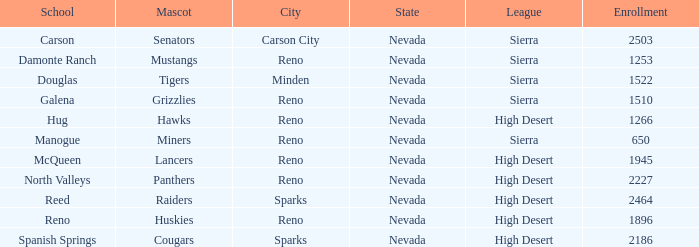What city and state are the miners located in? Reno, Nevada. 